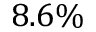Convert formula to latex. <formula><loc_0><loc_0><loc_500><loc_500>8 . 6 \%</formula> 